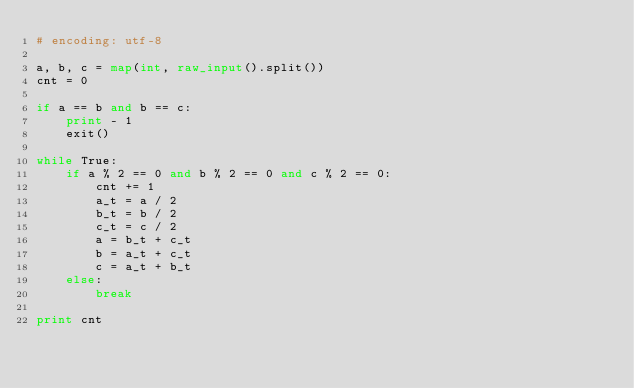Convert code to text. <code><loc_0><loc_0><loc_500><loc_500><_Python_># encoding: utf-8

a, b, c = map(int, raw_input().split())
cnt = 0

if a == b and b == c:
    print - 1
    exit()

while True:
    if a % 2 == 0 and b % 2 == 0 and c % 2 == 0:
        cnt += 1
        a_t = a / 2
        b_t = b / 2
        c_t = c / 2
        a = b_t + c_t
        b = a_t + c_t
        c = a_t + b_t
    else:
        break

print cnt
</code> 